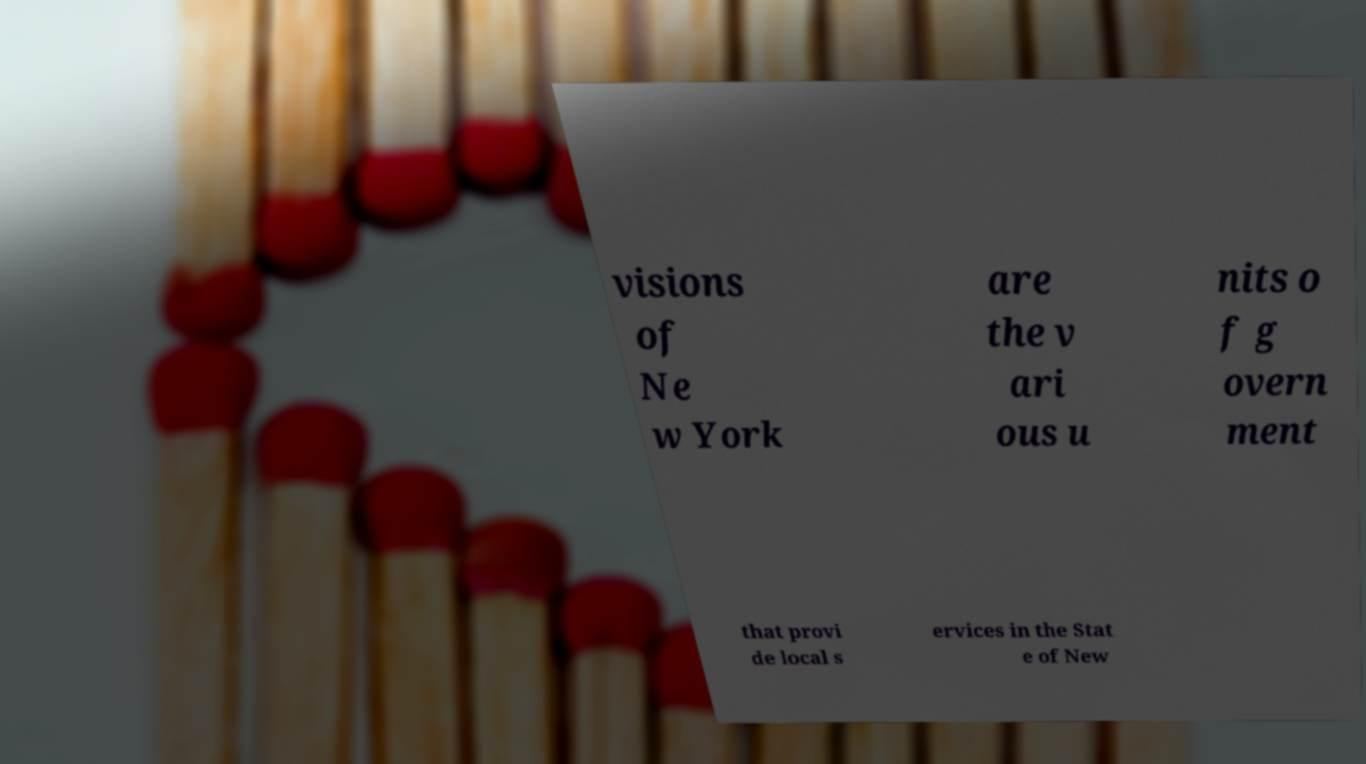Can you read and provide the text displayed in the image?This photo seems to have some interesting text. Can you extract and type it out for me? visions of Ne w York are the v ari ous u nits o f g overn ment that provi de local s ervices in the Stat e of New 